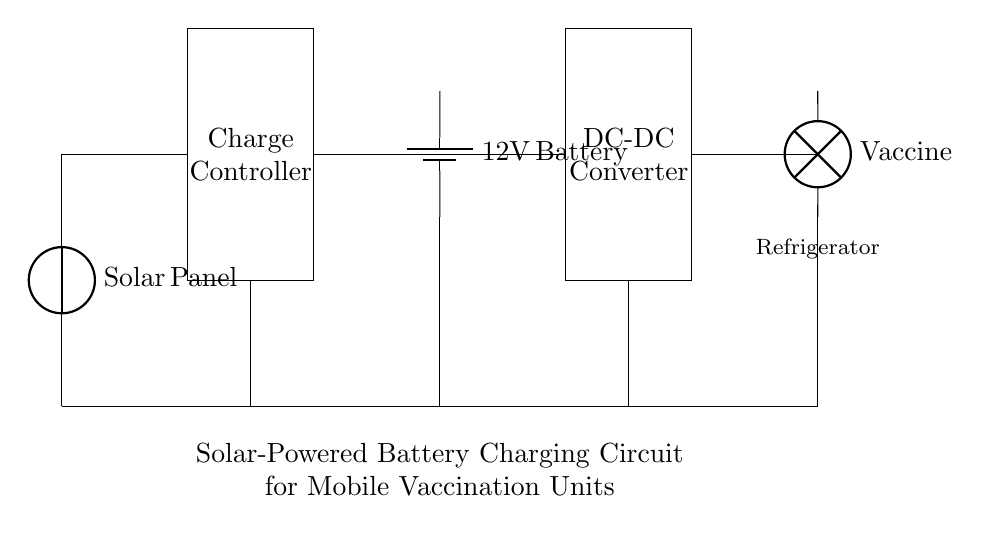What is the main energy source for this circuit? The main energy source is the Solar Panel, which converts sunlight into electrical energy to charge the battery.
Answer: Solar Panel What component regulates the charging of the battery? The component that regulates the charging of the battery is the Charge Controller, which ensures that the battery receives the correct voltage and current to avoid overcharging.
Answer: Charge Controller What voltage is the battery rated at? The battery is rated at 12V, as indicated directly on the component in the circuit.
Answer: 12V Which appliance is represented as the load in this circuit? The load in this circuit is the Vaccine Refrigerator, which is the appliance that uses the stored energy to keep vaccines at the required temperature.
Answer: Vaccine Refrigerator How many main components are used in this charging circuit? The circuit consists of five main components: Solar Panel, Charge Controller, Battery, DC-DC Converter, and Vaccine Refrigerator.
Answer: Five What does the DC-DC Converter do in this circuit? The DC-DC Converter adjusts the voltage output from the battery to the appropriate level required by the Vaccine Refrigerator, ensuring efficient and safe operation of the appliance.
Answer: Adjusts voltage What is the purpose of grounding in this circuit? Grounding provides a common return path for electric current, which enhances the safety and stability of the circuit by preventing electric shock and ensuring reliable operation of all components.
Answer: Safety and stability 